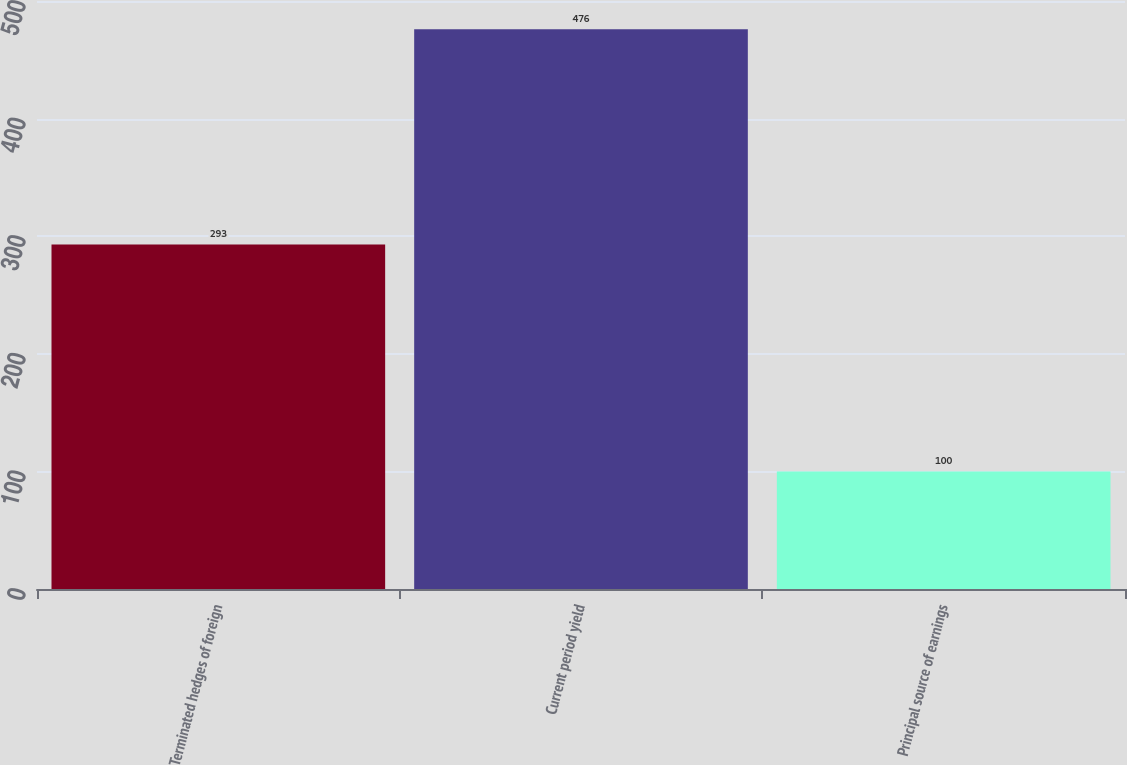Convert chart. <chart><loc_0><loc_0><loc_500><loc_500><bar_chart><fcel>Terminated hedges of foreign<fcel>Current period yield<fcel>Principal source of earnings<nl><fcel>293<fcel>476<fcel>100<nl></chart> 